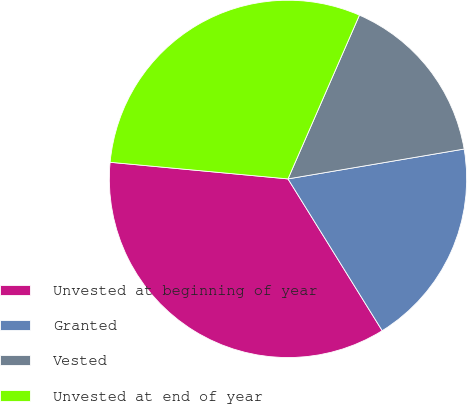Convert chart to OTSL. <chart><loc_0><loc_0><loc_500><loc_500><pie_chart><fcel>Unvested at beginning of year<fcel>Granted<fcel>Vested<fcel>Unvested at end of year<nl><fcel>35.32%<fcel>18.83%<fcel>15.78%<fcel>30.06%<nl></chart> 